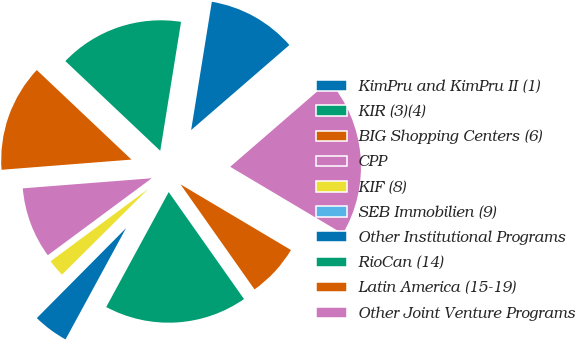Convert chart. <chart><loc_0><loc_0><loc_500><loc_500><pie_chart><fcel>KimPru and KimPru II (1)<fcel>KIR (3)(4)<fcel>BIG Shopping Centers (6)<fcel>CPP<fcel>KIF (8)<fcel>SEB Immobilien (9)<fcel>Other Institutional Programs<fcel>RioCan (14)<fcel>Latin America (15-19)<fcel>Other Joint Venture Programs<nl><fcel>11.1%<fcel>15.49%<fcel>13.3%<fcel>8.9%<fcel>2.31%<fcel>0.11%<fcel>4.51%<fcel>17.69%<fcel>6.7%<fcel>19.89%<nl></chart> 